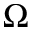Convert formula to latex. <formula><loc_0><loc_0><loc_500><loc_500>\Omega</formula> 